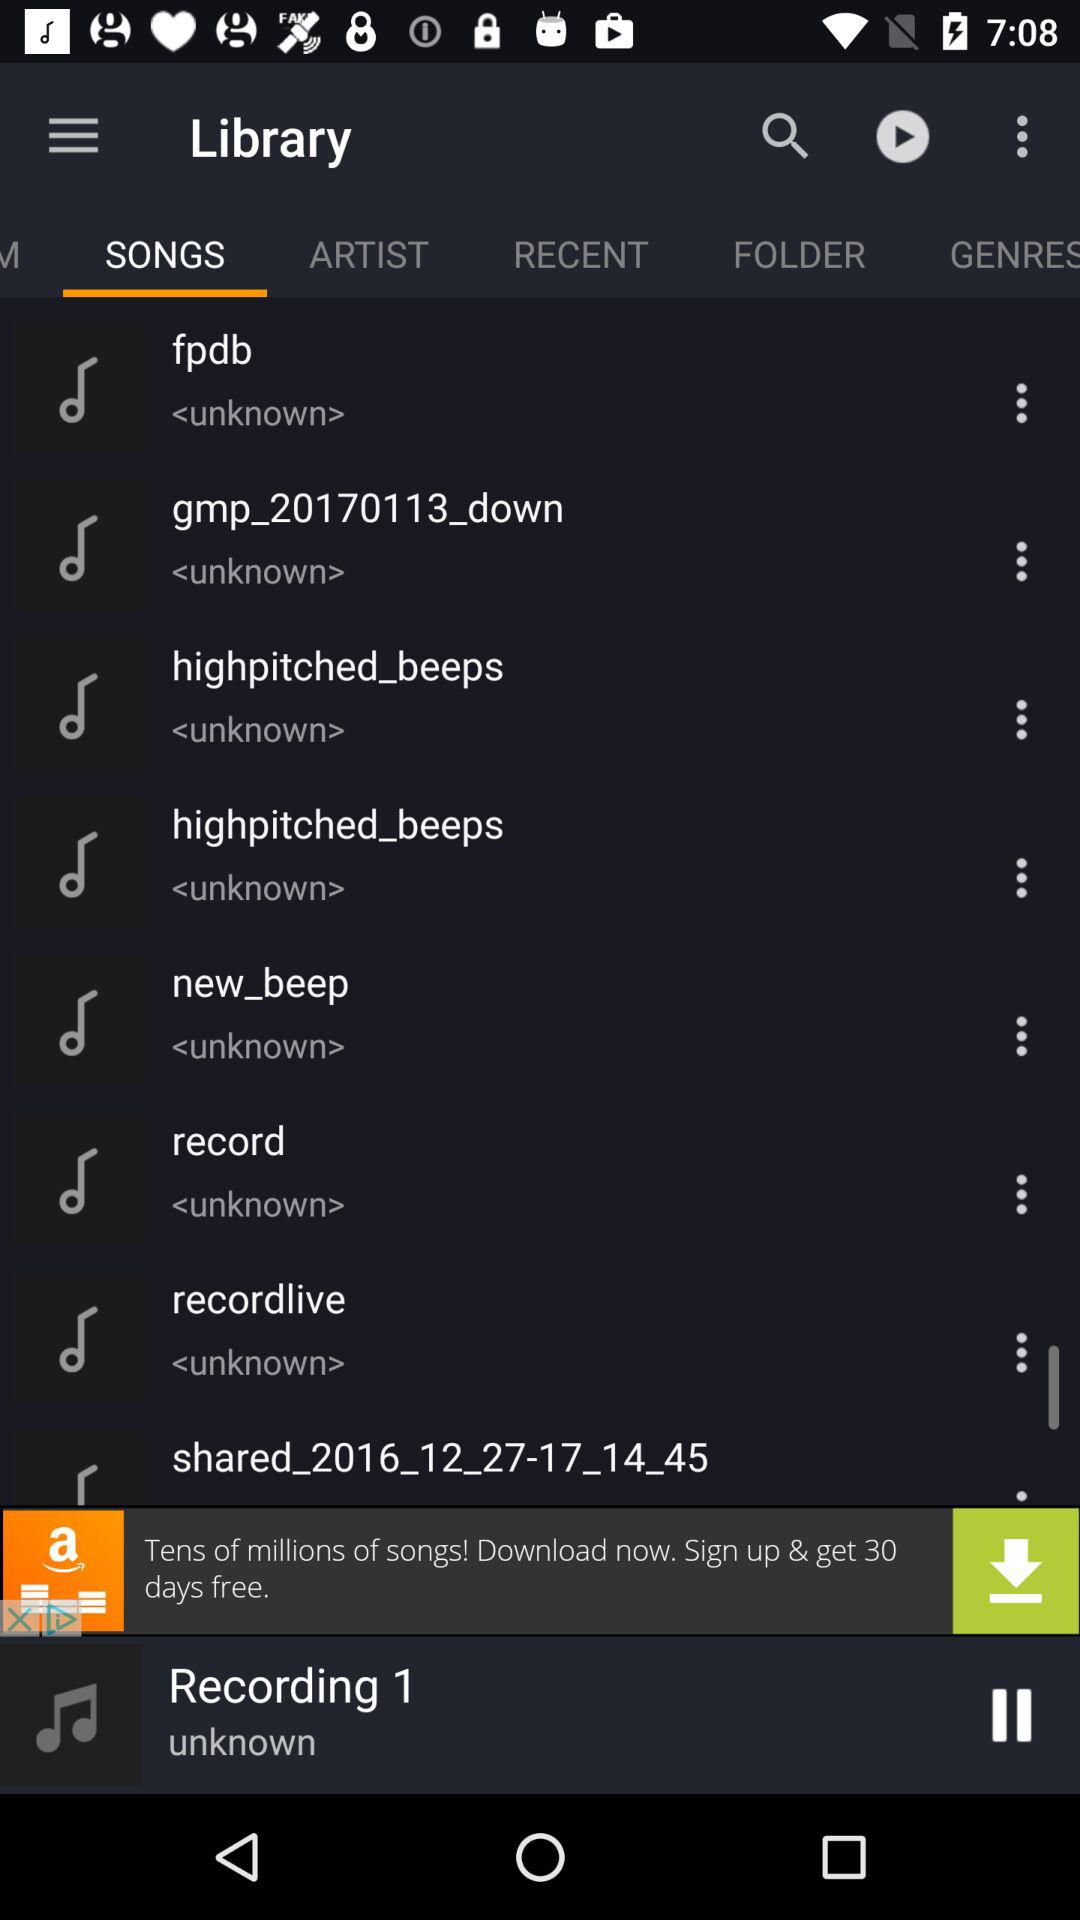Which option is selected? The selected option is "SONGS". 